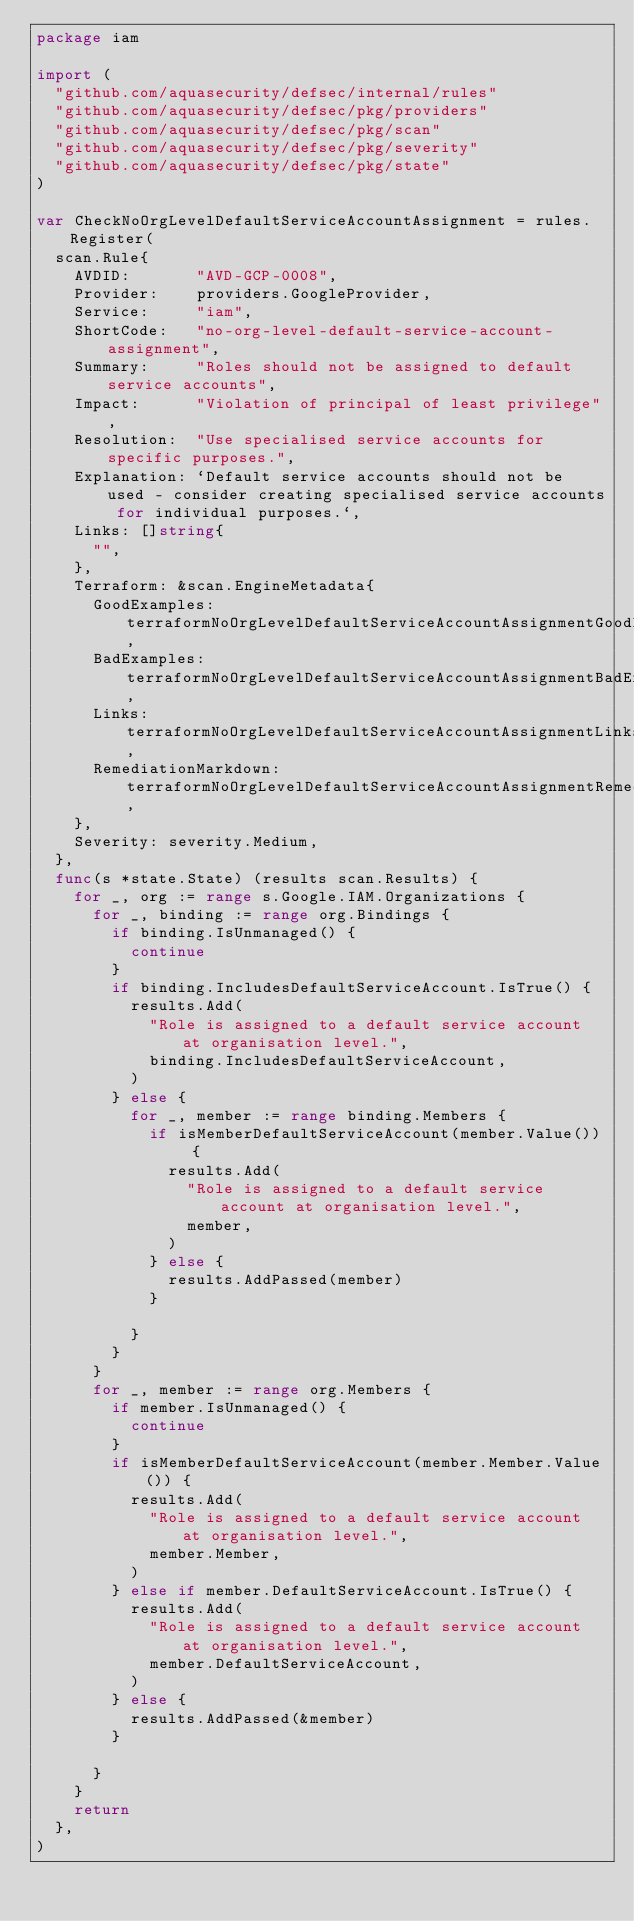<code> <loc_0><loc_0><loc_500><loc_500><_Go_>package iam

import (
	"github.com/aquasecurity/defsec/internal/rules"
	"github.com/aquasecurity/defsec/pkg/providers"
	"github.com/aquasecurity/defsec/pkg/scan"
	"github.com/aquasecurity/defsec/pkg/severity"
	"github.com/aquasecurity/defsec/pkg/state"
)

var CheckNoOrgLevelDefaultServiceAccountAssignment = rules.Register(
	scan.Rule{
		AVDID:       "AVD-GCP-0008",
		Provider:    providers.GoogleProvider,
		Service:     "iam",
		ShortCode:   "no-org-level-default-service-account-assignment",
		Summary:     "Roles should not be assigned to default service accounts",
		Impact:      "Violation of principal of least privilege",
		Resolution:  "Use specialised service accounts for specific purposes.",
		Explanation: `Default service accounts should not be used - consider creating specialised service accounts for individual purposes.`,
		Links: []string{
			"",
		},
		Terraform: &scan.EngineMetadata{
			GoodExamples:        terraformNoOrgLevelDefaultServiceAccountAssignmentGoodExamples,
			BadExamples:         terraformNoOrgLevelDefaultServiceAccountAssignmentBadExamples,
			Links:               terraformNoOrgLevelDefaultServiceAccountAssignmentLinks,
			RemediationMarkdown: terraformNoOrgLevelDefaultServiceAccountAssignmentRemediationMarkdown,
		},
		Severity: severity.Medium,
	},
	func(s *state.State) (results scan.Results) {
		for _, org := range s.Google.IAM.Organizations {
			for _, binding := range org.Bindings {
				if binding.IsUnmanaged() {
					continue
				}
				if binding.IncludesDefaultServiceAccount.IsTrue() {
					results.Add(
						"Role is assigned to a default service account at organisation level.",
						binding.IncludesDefaultServiceAccount,
					)
				} else {
					for _, member := range binding.Members {
						if isMemberDefaultServiceAccount(member.Value()) {
							results.Add(
								"Role is assigned to a default service account at organisation level.",
								member,
							)
						} else {
							results.AddPassed(member)
						}

					}
				}
			}
			for _, member := range org.Members {
				if member.IsUnmanaged() {
					continue
				}
				if isMemberDefaultServiceAccount(member.Member.Value()) {
					results.Add(
						"Role is assigned to a default service account at organisation level.",
						member.Member,
					)
				} else if member.DefaultServiceAccount.IsTrue() {
					results.Add(
						"Role is assigned to a default service account at organisation level.",
						member.DefaultServiceAccount,
					)
				} else {
					results.AddPassed(&member)
				}

			}
		}
		return
	},
)
</code> 